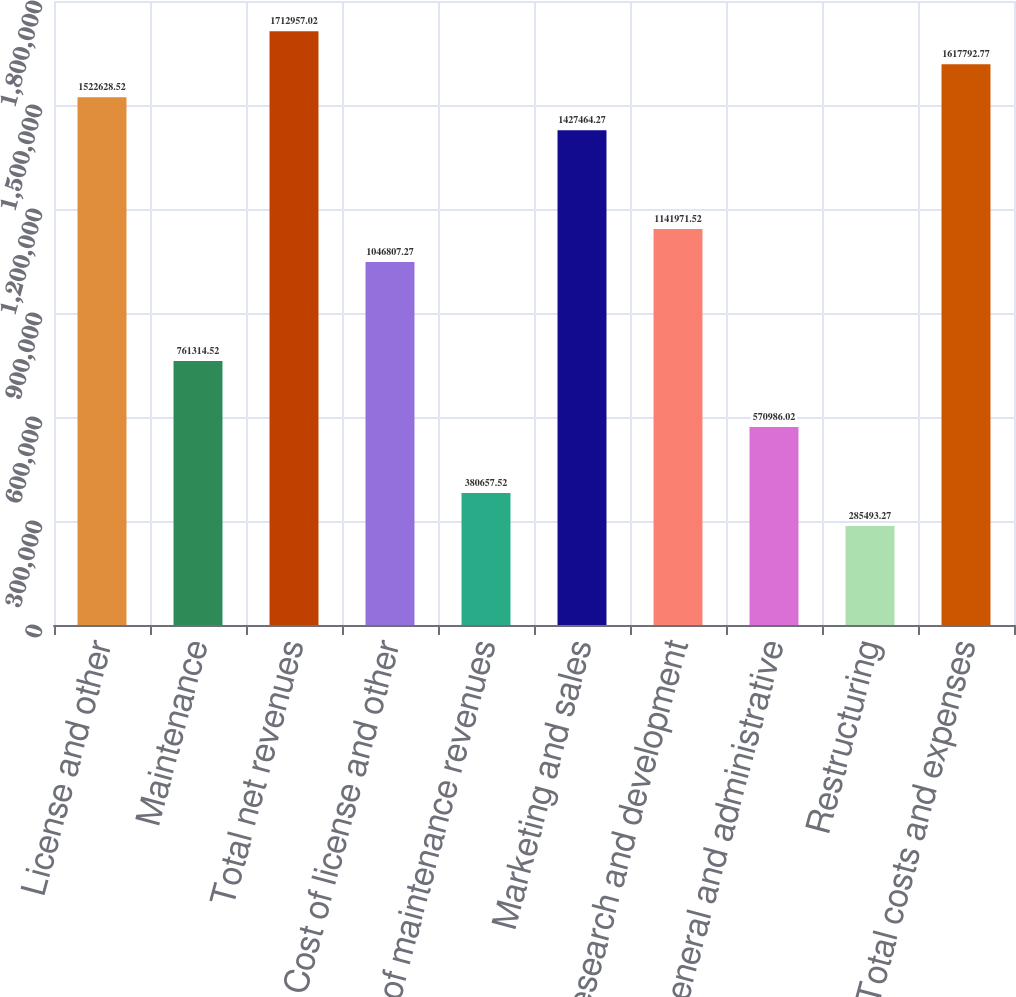Convert chart to OTSL. <chart><loc_0><loc_0><loc_500><loc_500><bar_chart><fcel>License and other<fcel>Maintenance<fcel>Total net revenues<fcel>Cost of license and other<fcel>Cost of maintenance revenues<fcel>Marketing and sales<fcel>Research and development<fcel>General and administrative<fcel>Restructuring<fcel>Total costs and expenses<nl><fcel>1.52263e+06<fcel>761315<fcel>1.71296e+06<fcel>1.04681e+06<fcel>380658<fcel>1.42746e+06<fcel>1.14197e+06<fcel>570986<fcel>285493<fcel>1.61779e+06<nl></chart> 